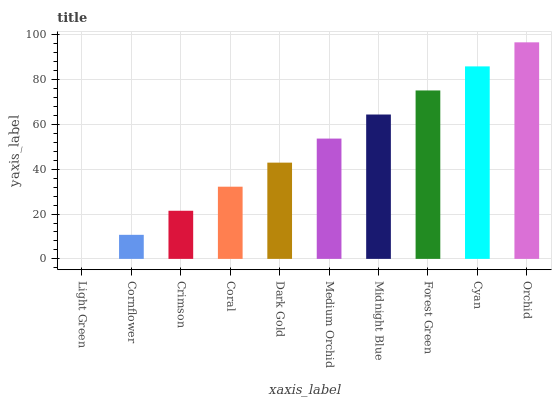Is Cornflower the minimum?
Answer yes or no. No. Is Cornflower the maximum?
Answer yes or no. No. Is Cornflower greater than Light Green?
Answer yes or no. Yes. Is Light Green less than Cornflower?
Answer yes or no. Yes. Is Light Green greater than Cornflower?
Answer yes or no. No. Is Cornflower less than Light Green?
Answer yes or no. No. Is Medium Orchid the high median?
Answer yes or no. Yes. Is Dark Gold the low median?
Answer yes or no. Yes. Is Cyan the high median?
Answer yes or no. No. Is Coral the low median?
Answer yes or no. No. 